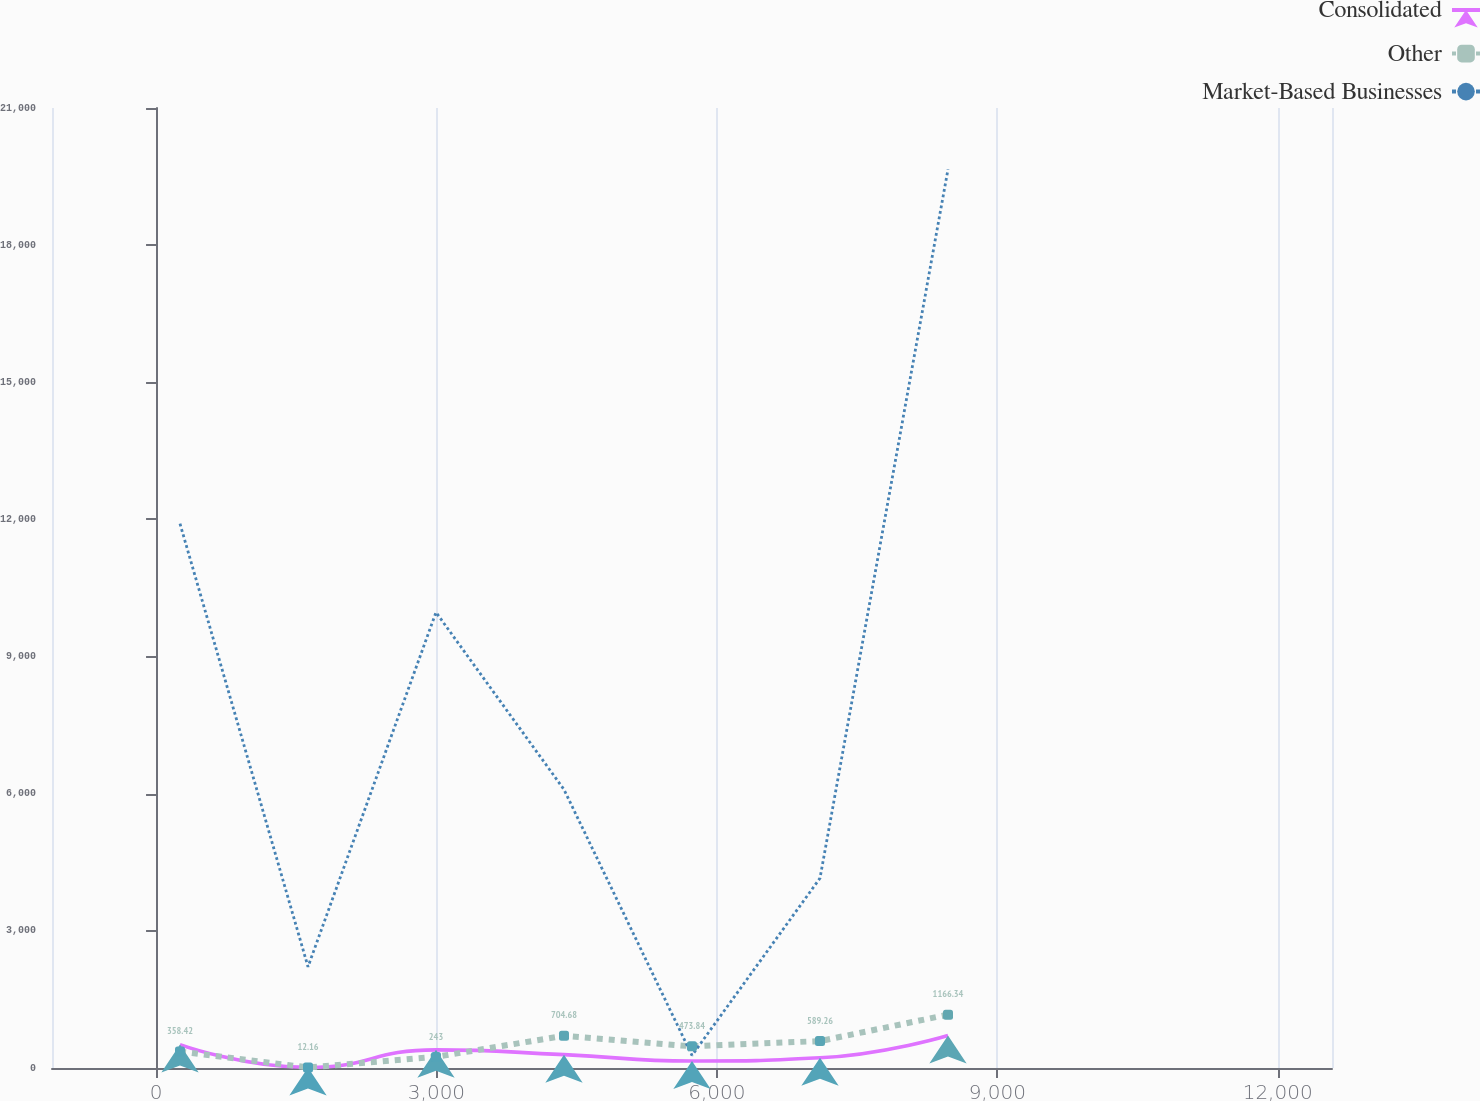Convert chart to OTSL. <chart><loc_0><loc_0><loc_500><loc_500><line_chart><ecel><fcel>Consolidated<fcel>Other<fcel>Market-Based Businesses<nl><fcel>256.18<fcel>512.15<fcel>358.42<fcel>11906.6<nl><fcel>1625.64<fcel>13.46<fcel>12.16<fcel>2213.91<nl><fcel>2995.1<fcel>397.06<fcel>243<fcel>9968.03<nl><fcel>4364.56<fcel>292.26<fcel>704.68<fcel>6090.97<nl><fcel>5734.02<fcel>152.86<fcel>473.84<fcel>275.38<nl><fcel>7103.48<fcel>222.56<fcel>589.26<fcel>4152.44<nl><fcel>8472.94<fcel>710.45<fcel>1166.34<fcel>19660.7<nl><fcel>13950.8<fcel>83.16<fcel>127.58<fcel>8029.5<nl></chart> 